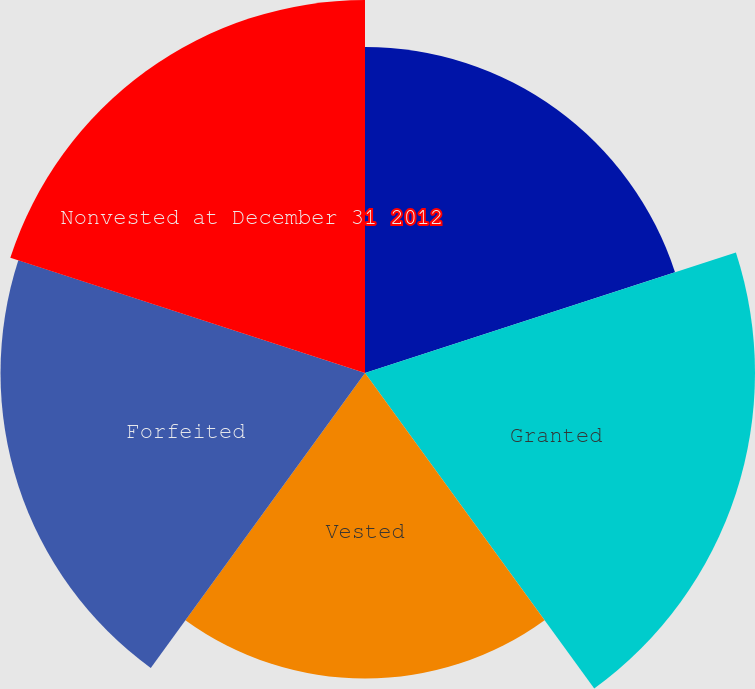<chart> <loc_0><loc_0><loc_500><loc_500><pie_chart><fcel>Nonvested at December 31 2011<fcel>Granted<fcel>Vested<fcel>Forfeited<fcel>Nonvested at December 31 2012<nl><fcel>18.53%<fcel>22.17%<fcel>17.37%<fcel>20.72%<fcel>21.2%<nl></chart> 